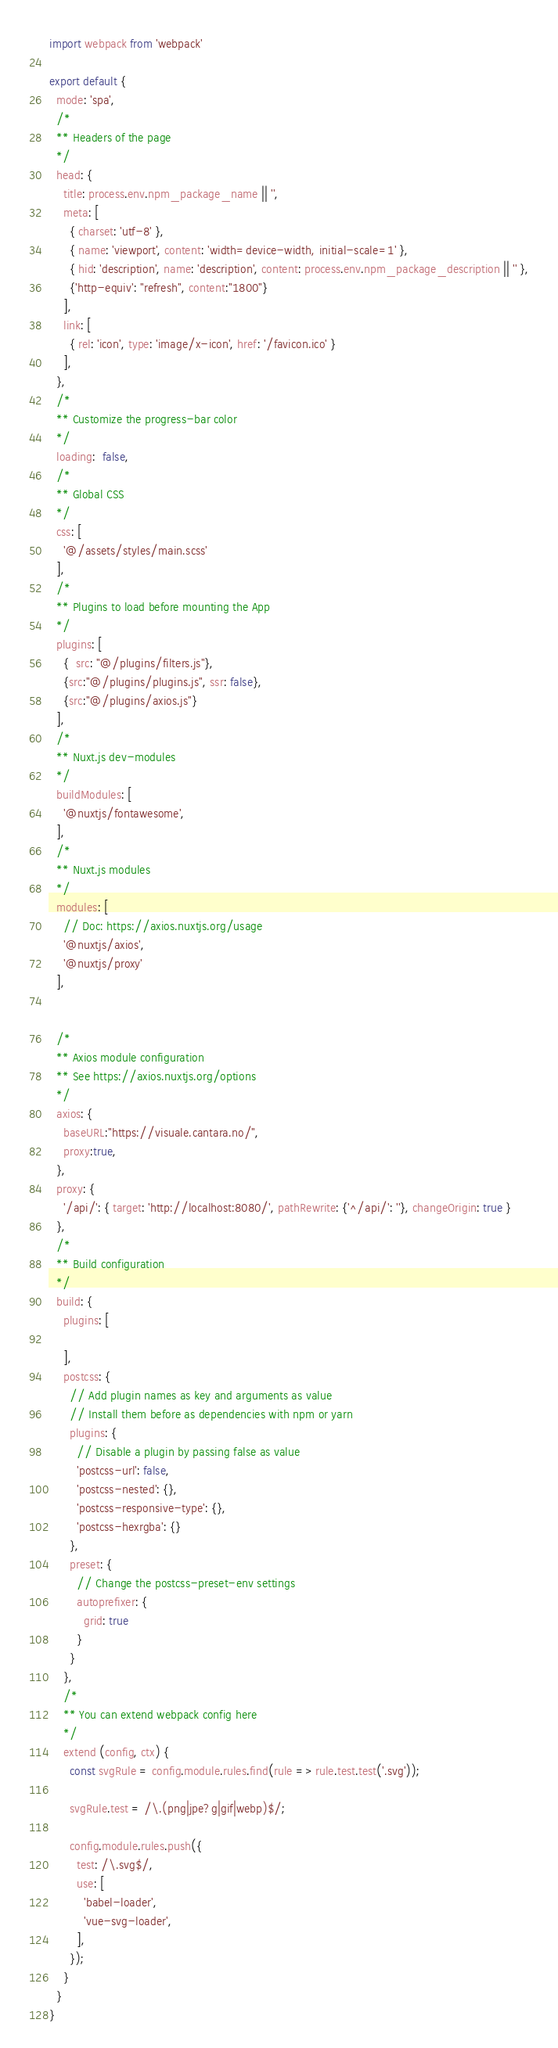Convert code to text. <code><loc_0><loc_0><loc_500><loc_500><_JavaScript_>import webpack from 'webpack'

export default {
  mode: 'spa',
  /*
  ** Headers of the page
  */
  head: {
    title: process.env.npm_package_name || '',
    meta: [
      { charset: 'utf-8' },
      { name: 'viewport', content: 'width=device-width, initial-scale=1' },
      { hid: 'description', name: 'description', content: process.env.npm_package_description || '' },
      {'http-equiv': "refresh", content:"1800"}
    ],
    link: [
      { rel: 'icon', type: 'image/x-icon', href: '/favicon.ico' }
    ],
  },
  /*
  ** Customize the progress-bar color
  */
  loading:  false,
  /*
  ** Global CSS
  */
  css: [
    '@/assets/styles/main.scss'
  ],
  /*
  ** Plugins to load before mounting the App
  */
  plugins: [
    {  src: "@/plugins/filters.js"},
    {src:"@/plugins/plugins.js", ssr: false},
    {src:"@/plugins/axios.js"}
  ],
  /*
  ** Nuxt.js dev-modules
  */
  buildModules: [
    '@nuxtjs/fontawesome',
  ],
  /*
  ** Nuxt.js modules
  */
  modules: [
    // Doc: https://axios.nuxtjs.org/usage
    '@nuxtjs/axios',
    '@nuxtjs/proxy'
  ],


  /*
  ** Axios module configuration
  ** See https://axios.nuxtjs.org/options
  */
  axios: {
    baseURL:"https://visuale.cantara.no/",
    proxy:true,
  },
  proxy: {
    '/api/': { target: 'http://localhost:8080/', pathRewrite: {'^/api/': ''}, changeOrigin: true }
  },
  /*
  ** Build configuration
  */
  build: {
    plugins: [

    ],
    postcss: {
      // Add plugin names as key and arguments as value
      // Install them before as dependencies with npm or yarn
      plugins: {
        // Disable a plugin by passing false as value
        'postcss-url': false,
        'postcss-nested': {},
        'postcss-responsive-type': {},
        'postcss-hexrgba': {}
      },
      preset: {
        // Change the postcss-preset-env settings
        autoprefixer: {
          grid: true
        }
      }
    },
    /*
    ** You can extend webpack config here
    */
    extend (config, ctx) {
      const svgRule = config.module.rules.find(rule => rule.test.test('.svg'));

      svgRule.test = /\.(png|jpe?g|gif|webp)$/;

      config.module.rules.push({
        test: /\.svg$/,
        use: [
          'babel-loader',
          'vue-svg-loader',
        ],
      });
    }
  }
}
</code> 